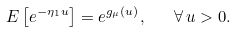<formula> <loc_0><loc_0><loc_500><loc_500>E \left [ e ^ { - \eta _ { 1 } u } \right ] = e ^ { g _ { \mu } ( u ) } , \quad \forall \, u > 0 .</formula> 